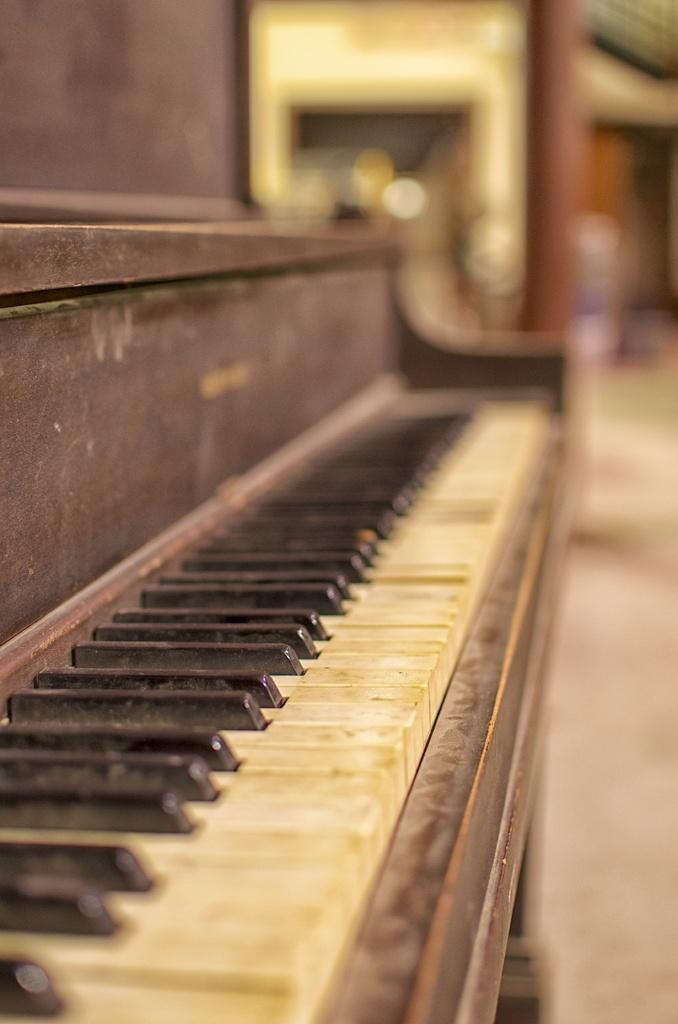What type of musical instrument is in the image? There is a wooden piano in the image. Where is the piano located? The piano is on the floor. What colors are the buttons on the piano? The piano has a combination of white and black buttons. What other wooden structure is visible in the image? There is a wooden pillar visible in the image. What part of a building can be seen in the image? There is a roof top in the image. What type of wool is being used to shade the piano in the image? There is no wool or shading present in the image; the piano is simply on the floor with its buttons visible. 